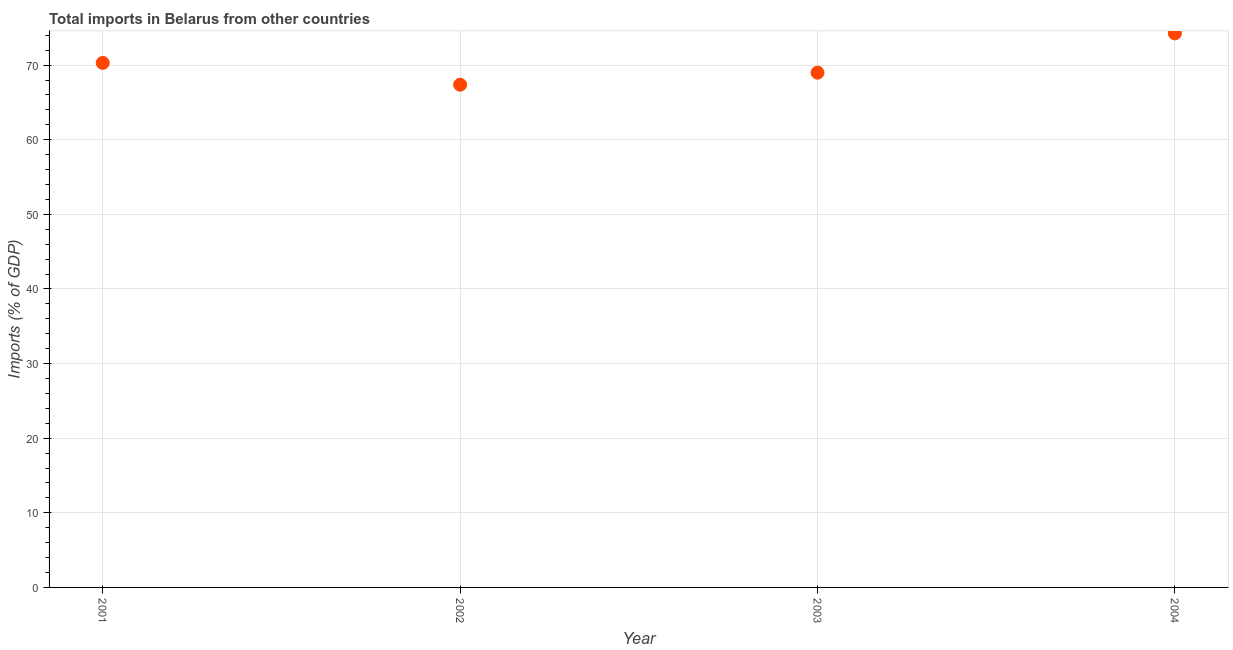What is the total imports in 2003?
Give a very brief answer. 68.99. Across all years, what is the maximum total imports?
Provide a short and direct response. 74.25. Across all years, what is the minimum total imports?
Provide a succinct answer. 67.37. In which year was the total imports maximum?
Provide a short and direct response. 2004. In which year was the total imports minimum?
Your answer should be compact. 2002. What is the sum of the total imports?
Offer a terse response. 280.91. What is the difference between the total imports in 2003 and 2004?
Give a very brief answer. -5.26. What is the average total imports per year?
Provide a short and direct response. 70.23. What is the median total imports?
Your response must be concise. 69.64. In how many years, is the total imports greater than 24 %?
Your answer should be very brief. 4. What is the ratio of the total imports in 2002 to that in 2003?
Provide a succinct answer. 0.98. What is the difference between the highest and the second highest total imports?
Ensure brevity in your answer.  3.95. What is the difference between the highest and the lowest total imports?
Your answer should be compact. 6.88. Does the total imports monotonically increase over the years?
Your response must be concise. No. How many dotlines are there?
Offer a terse response. 1. What is the difference between two consecutive major ticks on the Y-axis?
Your response must be concise. 10. What is the title of the graph?
Provide a short and direct response. Total imports in Belarus from other countries. What is the label or title of the Y-axis?
Your answer should be compact. Imports (% of GDP). What is the Imports (% of GDP) in 2001?
Give a very brief answer. 70.3. What is the Imports (% of GDP) in 2002?
Provide a short and direct response. 67.37. What is the Imports (% of GDP) in 2003?
Make the answer very short. 68.99. What is the Imports (% of GDP) in 2004?
Offer a terse response. 74.25. What is the difference between the Imports (% of GDP) in 2001 and 2002?
Ensure brevity in your answer.  2.92. What is the difference between the Imports (% of GDP) in 2001 and 2003?
Ensure brevity in your answer.  1.31. What is the difference between the Imports (% of GDP) in 2001 and 2004?
Make the answer very short. -3.95. What is the difference between the Imports (% of GDP) in 2002 and 2003?
Give a very brief answer. -1.61. What is the difference between the Imports (% of GDP) in 2002 and 2004?
Ensure brevity in your answer.  -6.88. What is the difference between the Imports (% of GDP) in 2003 and 2004?
Keep it short and to the point. -5.26. What is the ratio of the Imports (% of GDP) in 2001 to that in 2002?
Offer a very short reply. 1.04. What is the ratio of the Imports (% of GDP) in 2001 to that in 2004?
Make the answer very short. 0.95. What is the ratio of the Imports (% of GDP) in 2002 to that in 2003?
Provide a short and direct response. 0.98. What is the ratio of the Imports (% of GDP) in 2002 to that in 2004?
Keep it short and to the point. 0.91. What is the ratio of the Imports (% of GDP) in 2003 to that in 2004?
Provide a short and direct response. 0.93. 